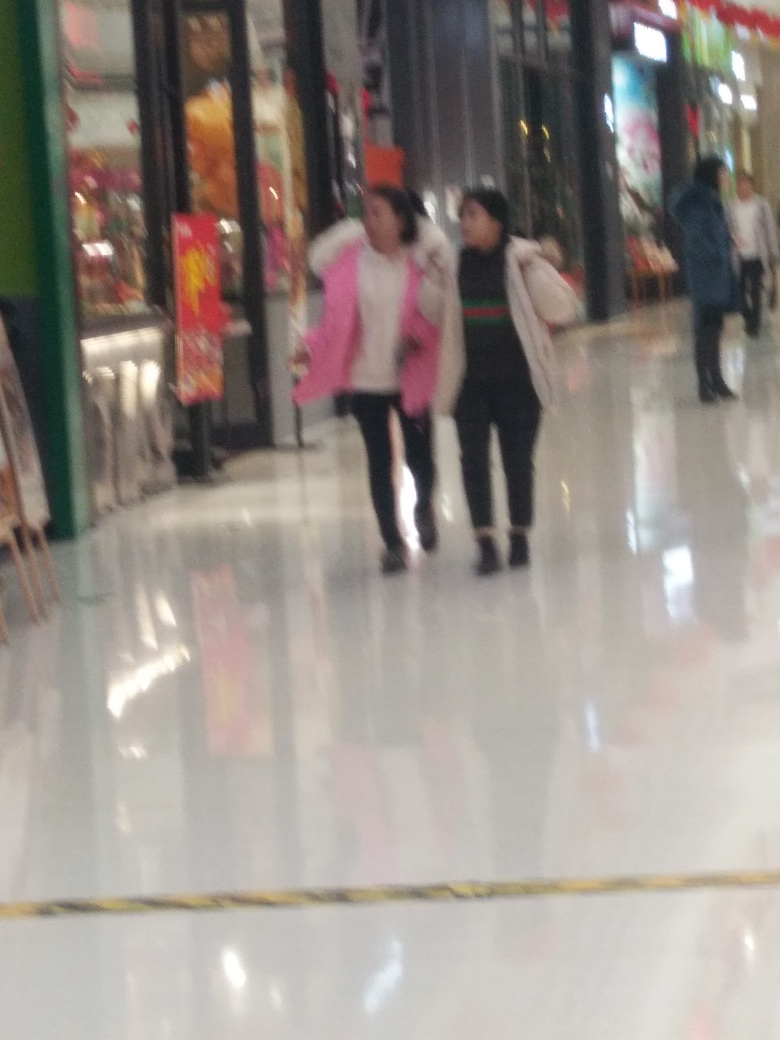What kind of environment is depicted in this image? The image shows an indoor setting that appears to be a shopping mall. It features a clean, reflective floor, several commercial stores with bright displays, and people walking, suggesting a public, commercial environment. 